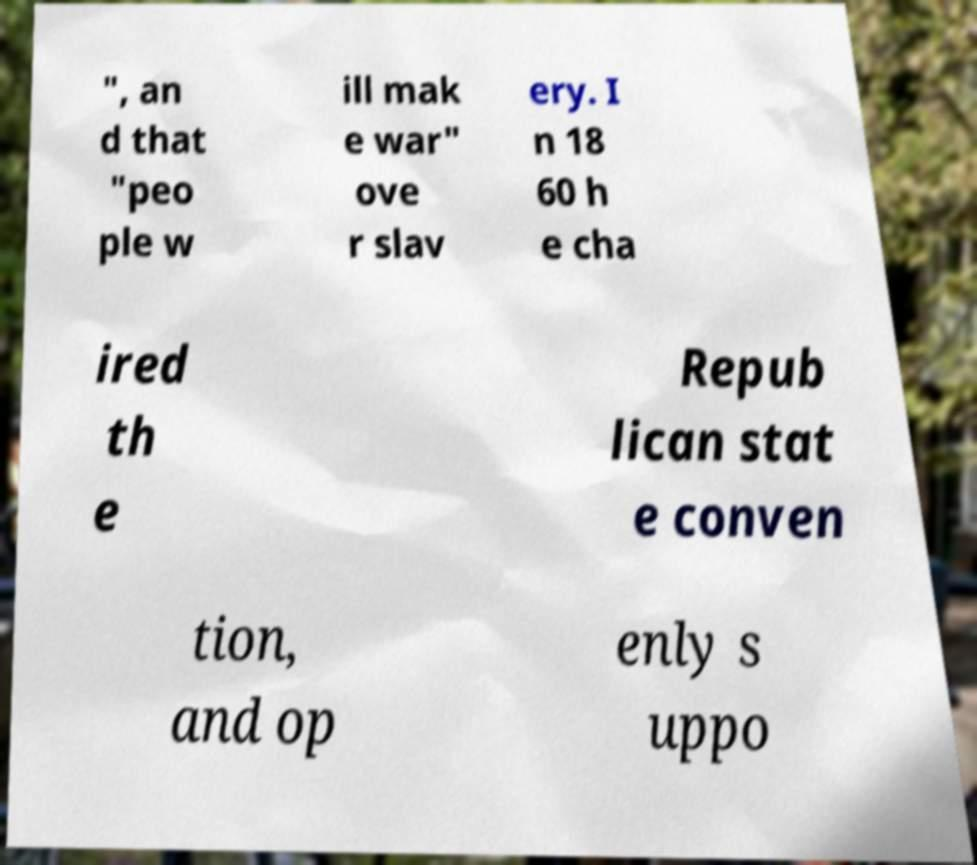There's text embedded in this image that I need extracted. Can you transcribe it verbatim? ", an d that "peo ple w ill mak e war" ove r slav ery. I n 18 60 h e cha ired th e Repub lican stat e conven tion, and op enly s uppo 